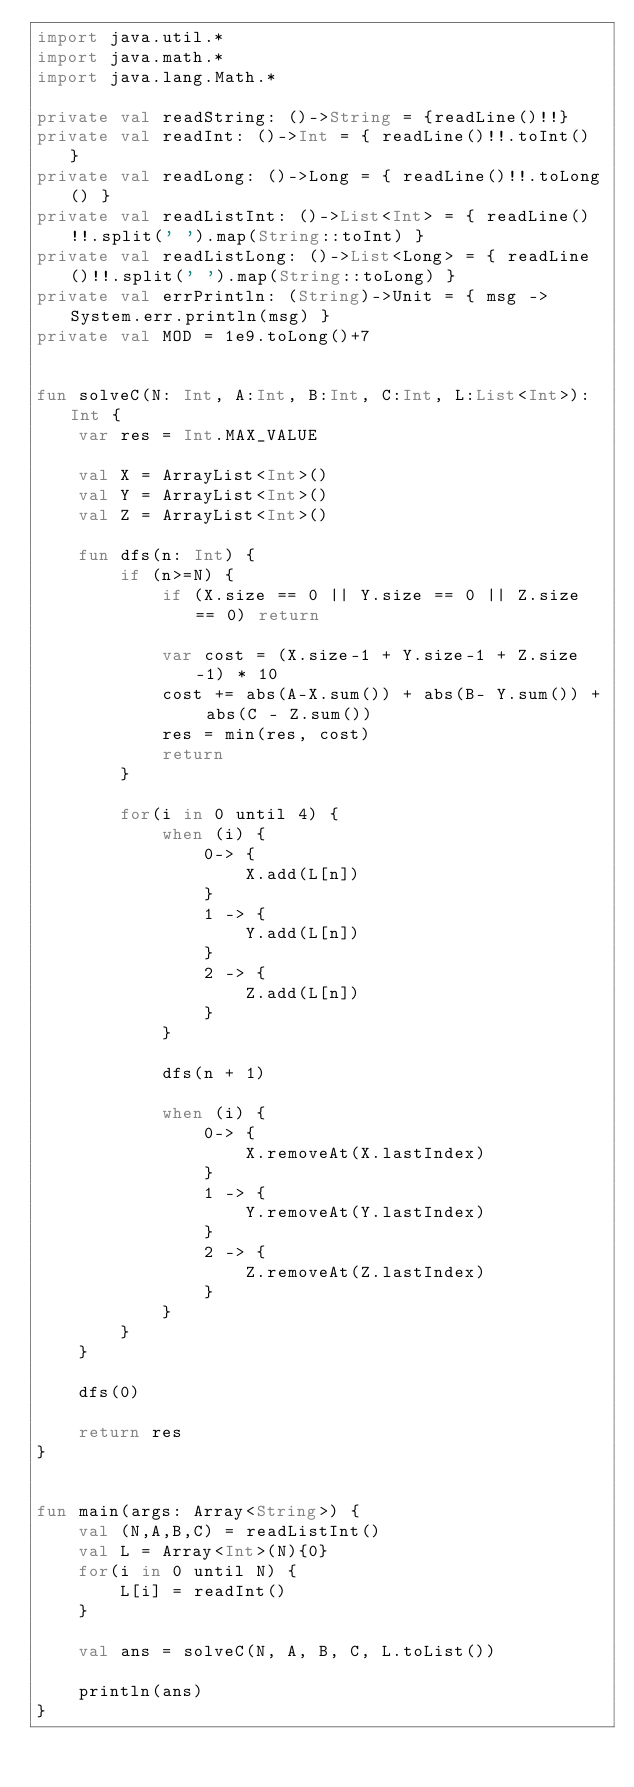Convert code to text. <code><loc_0><loc_0><loc_500><loc_500><_Kotlin_>import java.util.*
import java.math.*
import java.lang.Math.*

private val readString: ()->String = {readLine()!!}
private val readInt: ()->Int = { readLine()!!.toInt() }
private val readLong: ()->Long = { readLine()!!.toLong() }
private val readListInt: ()->List<Int> = { readLine()!!.split(' ').map(String::toInt) }
private val readListLong: ()->List<Long> = { readLine()!!.split(' ').map(String::toLong) }
private val errPrintln: (String)->Unit = { msg -> System.err.println(msg) }
private val MOD = 1e9.toLong()+7


fun solveC(N: Int, A:Int, B:Int, C:Int, L:List<Int>): Int {
    var res = Int.MAX_VALUE

    val X = ArrayList<Int>()
    val Y = ArrayList<Int>()
    val Z = ArrayList<Int>()

    fun dfs(n: Int) {
        if (n>=N) {
            if (X.size == 0 || Y.size == 0 || Z.size == 0) return

            var cost = (X.size-1 + Y.size-1 + Z.size-1) * 10
            cost += abs(A-X.sum()) + abs(B- Y.sum()) + abs(C - Z.sum())
            res = min(res, cost)
            return
        }

        for(i in 0 until 4) {
            when (i) {
                0-> {
                    X.add(L[n])
                }
                1 -> {
                    Y.add(L[n])
                }
                2 -> {
                    Z.add(L[n])
                }
            }

            dfs(n + 1)

            when (i) {
                0-> {
                    X.removeAt(X.lastIndex)
                }
                1 -> {
                    Y.removeAt(Y.lastIndex)
                }
                2 -> {
                    Z.removeAt(Z.lastIndex)
                }
            }
        }
    }

    dfs(0)

    return res
}


fun main(args: Array<String>) {
    val (N,A,B,C) = readListInt()
    val L = Array<Int>(N){0}
    for(i in 0 until N) {
        L[i] = readInt()
    }

    val ans = solveC(N, A, B, C, L.toList())

    println(ans)
}
</code> 